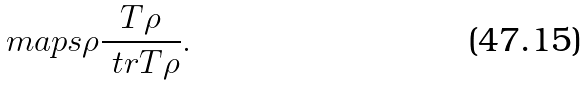<formula> <loc_0><loc_0><loc_500><loc_500>\ m a p s { \rho } { \frac { T \rho } { \ t r { T \rho } } } .</formula> 